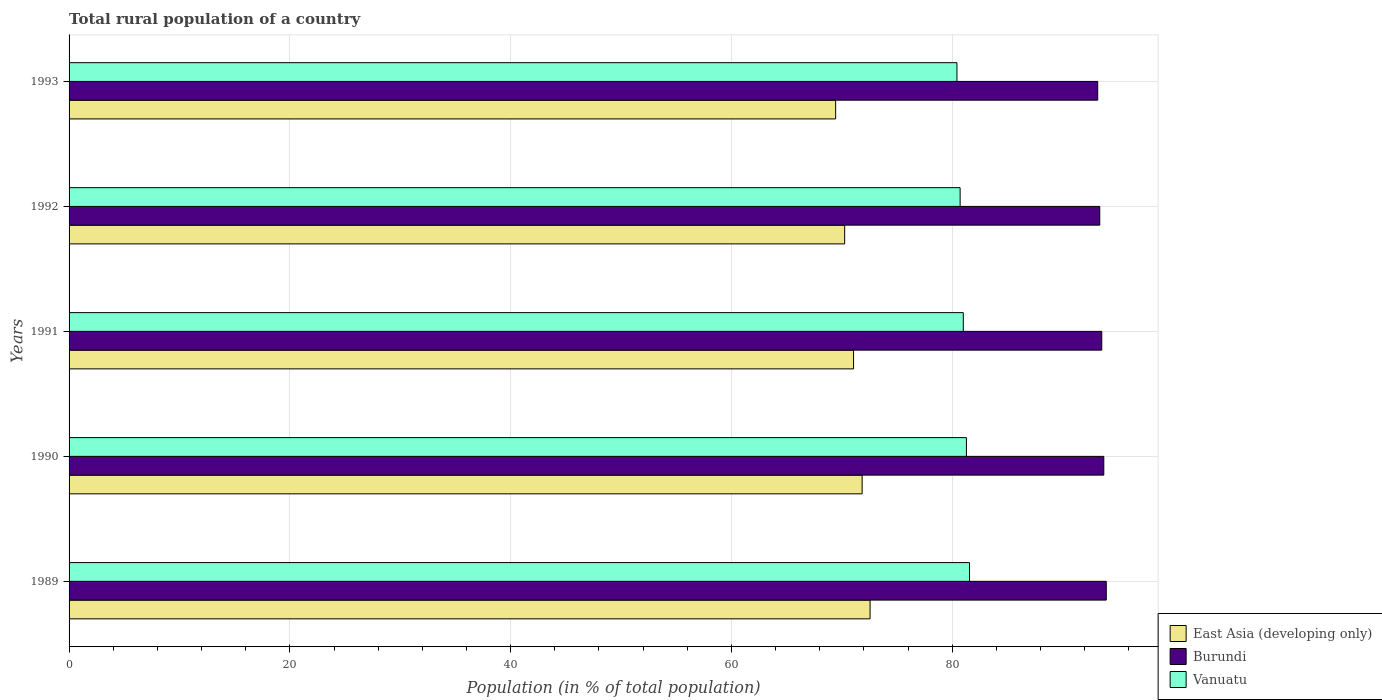How many groups of bars are there?
Offer a very short reply. 5. In how many cases, is the number of bars for a given year not equal to the number of legend labels?
Offer a very short reply. 0. What is the rural population in East Asia (developing only) in 1989?
Give a very brief answer. 72.56. Across all years, what is the maximum rural population in East Asia (developing only)?
Your answer should be very brief. 72.56. Across all years, what is the minimum rural population in Vanuatu?
Provide a short and direct response. 80.43. What is the total rural population in East Asia (developing only) in the graph?
Offer a very short reply. 355.15. What is the difference between the rural population in East Asia (developing only) in 1989 and that in 1993?
Your answer should be very brief. 3.12. What is the difference between the rural population in Burundi in 1991 and the rural population in Vanuatu in 1989?
Offer a terse response. 11.98. What is the average rural population in Burundi per year?
Provide a succinct answer. 93.55. In the year 1989, what is the difference between the rural population in Vanuatu and rural population in Burundi?
Provide a succinct answer. -12.39. In how many years, is the rural population in Vanuatu greater than 64 %?
Provide a short and direct response. 5. What is the ratio of the rural population in Burundi in 1992 to that in 1993?
Ensure brevity in your answer.  1. Is the rural population in Burundi in 1989 less than that in 1991?
Your answer should be very brief. No. Is the difference between the rural population in Vanuatu in 1992 and 1993 greater than the difference between the rural population in Burundi in 1992 and 1993?
Give a very brief answer. Yes. What is the difference between the highest and the second highest rural population in East Asia (developing only)?
Ensure brevity in your answer.  0.72. What is the difference between the highest and the lowest rural population in Burundi?
Keep it short and to the point. 0.78. What does the 3rd bar from the top in 1990 represents?
Offer a very short reply. East Asia (developing only). What does the 2nd bar from the bottom in 1990 represents?
Provide a succinct answer. Burundi. Is it the case that in every year, the sum of the rural population in Vanuatu and rural population in East Asia (developing only) is greater than the rural population in Burundi?
Make the answer very short. Yes. How many years are there in the graph?
Offer a terse response. 5. Are the values on the major ticks of X-axis written in scientific E-notation?
Give a very brief answer. No. Does the graph contain any zero values?
Your answer should be compact. No. Where does the legend appear in the graph?
Ensure brevity in your answer.  Bottom right. How many legend labels are there?
Provide a short and direct response. 3. What is the title of the graph?
Your answer should be very brief. Total rural population of a country. Does "Sint Maarten (Dutch part)" appear as one of the legend labels in the graph?
Offer a terse response. No. What is the label or title of the X-axis?
Your answer should be compact. Population (in % of total population). What is the label or title of the Y-axis?
Provide a short and direct response. Years. What is the Population (in % of total population) in East Asia (developing only) in 1989?
Give a very brief answer. 72.56. What is the Population (in % of total population) of Burundi in 1989?
Keep it short and to the point. 93.95. What is the Population (in % of total population) of Vanuatu in 1989?
Give a very brief answer. 81.56. What is the Population (in % of total population) of East Asia (developing only) in 1990?
Give a very brief answer. 71.84. What is the Population (in % of total population) in Burundi in 1990?
Provide a short and direct response. 93.73. What is the Population (in % of total population) of Vanuatu in 1990?
Your response must be concise. 81.28. What is the Population (in % of total population) of East Asia (developing only) in 1991?
Provide a short and direct response. 71.06. What is the Population (in % of total population) in Burundi in 1991?
Keep it short and to the point. 93.55. What is the Population (in % of total population) of Vanuatu in 1991?
Ensure brevity in your answer.  81. What is the Population (in % of total population) in East Asia (developing only) in 1992?
Give a very brief answer. 70.26. What is the Population (in % of total population) in Burundi in 1992?
Provide a short and direct response. 93.36. What is the Population (in % of total population) of Vanuatu in 1992?
Keep it short and to the point. 80.72. What is the Population (in % of total population) of East Asia (developing only) in 1993?
Offer a terse response. 69.44. What is the Population (in % of total population) of Burundi in 1993?
Make the answer very short. 93.18. What is the Population (in % of total population) in Vanuatu in 1993?
Give a very brief answer. 80.43. Across all years, what is the maximum Population (in % of total population) of East Asia (developing only)?
Ensure brevity in your answer.  72.56. Across all years, what is the maximum Population (in % of total population) in Burundi?
Give a very brief answer. 93.95. Across all years, what is the maximum Population (in % of total population) of Vanuatu?
Offer a terse response. 81.56. Across all years, what is the minimum Population (in % of total population) of East Asia (developing only)?
Your answer should be compact. 69.44. Across all years, what is the minimum Population (in % of total population) in Burundi?
Make the answer very short. 93.18. Across all years, what is the minimum Population (in % of total population) of Vanuatu?
Make the answer very short. 80.43. What is the total Population (in % of total population) of East Asia (developing only) in the graph?
Offer a terse response. 355.15. What is the total Population (in % of total population) of Burundi in the graph?
Give a very brief answer. 467.77. What is the total Population (in % of total population) in Vanuatu in the graph?
Ensure brevity in your answer.  404.99. What is the difference between the Population (in % of total population) in East Asia (developing only) in 1989 and that in 1990?
Your response must be concise. 0.72. What is the difference between the Population (in % of total population) in Burundi in 1989 and that in 1990?
Your answer should be compact. 0.22. What is the difference between the Population (in % of total population) in Vanuatu in 1989 and that in 1990?
Offer a terse response. 0.28. What is the difference between the Population (in % of total population) of East Asia (developing only) in 1989 and that in 1991?
Keep it short and to the point. 1.5. What is the difference between the Population (in % of total population) in Burundi in 1989 and that in 1991?
Your response must be concise. 0.41. What is the difference between the Population (in % of total population) of Vanuatu in 1989 and that in 1991?
Ensure brevity in your answer.  0.56. What is the difference between the Population (in % of total population) in East Asia (developing only) in 1989 and that in 1992?
Offer a terse response. 2.3. What is the difference between the Population (in % of total population) in Burundi in 1989 and that in 1992?
Your answer should be compact. 0.59. What is the difference between the Population (in % of total population) in East Asia (developing only) in 1989 and that in 1993?
Provide a succinct answer. 3.12. What is the difference between the Population (in % of total population) of Burundi in 1989 and that in 1993?
Your answer should be compact. 0.78. What is the difference between the Population (in % of total population) in Vanuatu in 1989 and that in 1993?
Keep it short and to the point. 1.14. What is the difference between the Population (in % of total population) of East Asia (developing only) in 1990 and that in 1991?
Make the answer very short. 0.78. What is the difference between the Population (in % of total population) of Burundi in 1990 and that in 1991?
Your answer should be compact. 0.18. What is the difference between the Population (in % of total population) of Vanuatu in 1990 and that in 1991?
Keep it short and to the point. 0.28. What is the difference between the Population (in % of total population) in East Asia (developing only) in 1990 and that in 1992?
Your response must be concise. 1.58. What is the difference between the Population (in % of total population) in Burundi in 1990 and that in 1992?
Provide a short and direct response. 0.37. What is the difference between the Population (in % of total population) in Vanuatu in 1990 and that in 1992?
Your response must be concise. 0.57. What is the difference between the Population (in % of total population) of East Asia (developing only) in 1990 and that in 1993?
Offer a very short reply. 2.4. What is the difference between the Population (in % of total population) of Burundi in 1990 and that in 1993?
Provide a short and direct response. 0.55. What is the difference between the Population (in % of total population) in Vanuatu in 1990 and that in 1993?
Provide a succinct answer. 0.86. What is the difference between the Population (in % of total population) in East Asia (developing only) in 1991 and that in 1992?
Your answer should be compact. 0.8. What is the difference between the Population (in % of total population) in Burundi in 1991 and that in 1992?
Keep it short and to the point. 0.18. What is the difference between the Population (in % of total population) in Vanuatu in 1991 and that in 1992?
Keep it short and to the point. 0.29. What is the difference between the Population (in % of total population) in East Asia (developing only) in 1991 and that in 1993?
Keep it short and to the point. 1.62. What is the difference between the Population (in % of total population) in Burundi in 1991 and that in 1993?
Make the answer very short. 0.37. What is the difference between the Population (in % of total population) of Vanuatu in 1991 and that in 1993?
Offer a terse response. 0.58. What is the difference between the Population (in % of total population) of East Asia (developing only) in 1992 and that in 1993?
Ensure brevity in your answer.  0.82. What is the difference between the Population (in % of total population) of Burundi in 1992 and that in 1993?
Your answer should be compact. 0.19. What is the difference between the Population (in % of total population) of Vanuatu in 1992 and that in 1993?
Offer a terse response. 0.29. What is the difference between the Population (in % of total population) of East Asia (developing only) in 1989 and the Population (in % of total population) of Burundi in 1990?
Offer a very short reply. -21.17. What is the difference between the Population (in % of total population) of East Asia (developing only) in 1989 and the Population (in % of total population) of Vanuatu in 1990?
Your answer should be very brief. -8.73. What is the difference between the Population (in % of total population) in Burundi in 1989 and the Population (in % of total population) in Vanuatu in 1990?
Your response must be concise. 12.67. What is the difference between the Population (in % of total population) of East Asia (developing only) in 1989 and the Population (in % of total population) of Burundi in 1991?
Make the answer very short. -20.99. What is the difference between the Population (in % of total population) of East Asia (developing only) in 1989 and the Population (in % of total population) of Vanuatu in 1991?
Your response must be concise. -8.44. What is the difference between the Population (in % of total population) of Burundi in 1989 and the Population (in % of total population) of Vanuatu in 1991?
Ensure brevity in your answer.  12.95. What is the difference between the Population (in % of total population) in East Asia (developing only) in 1989 and the Population (in % of total population) in Burundi in 1992?
Your answer should be compact. -20.81. What is the difference between the Population (in % of total population) of East Asia (developing only) in 1989 and the Population (in % of total population) of Vanuatu in 1992?
Your response must be concise. -8.16. What is the difference between the Population (in % of total population) in Burundi in 1989 and the Population (in % of total population) in Vanuatu in 1992?
Offer a very short reply. 13.24. What is the difference between the Population (in % of total population) in East Asia (developing only) in 1989 and the Population (in % of total population) in Burundi in 1993?
Keep it short and to the point. -20.62. What is the difference between the Population (in % of total population) of East Asia (developing only) in 1989 and the Population (in % of total population) of Vanuatu in 1993?
Offer a very short reply. -7.87. What is the difference between the Population (in % of total population) in Burundi in 1989 and the Population (in % of total population) in Vanuatu in 1993?
Your response must be concise. 13.53. What is the difference between the Population (in % of total population) in East Asia (developing only) in 1990 and the Population (in % of total population) in Burundi in 1991?
Provide a succinct answer. -21.71. What is the difference between the Population (in % of total population) in East Asia (developing only) in 1990 and the Population (in % of total population) in Vanuatu in 1991?
Offer a very short reply. -9.16. What is the difference between the Population (in % of total population) in Burundi in 1990 and the Population (in % of total population) in Vanuatu in 1991?
Give a very brief answer. 12.73. What is the difference between the Population (in % of total population) of East Asia (developing only) in 1990 and the Population (in % of total population) of Burundi in 1992?
Give a very brief answer. -21.52. What is the difference between the Population (in % of total population) of East Asia (developing only) in 1990 and the Population (in % of total population) of Vanuatu in 1992?
Offer a very short reply. -8.88. What is the difference between the Population (in % of total population) of Burundi in 1990 and the Population (in % of total population) of Vanuatu in 1992?
Your response must be concise. 13.01. What is the difference between the Population (in % of total population) of East Asia (developing only) in 1990 and the Population (in % of total population) of Burundi in 1993?
Give a very brief answer. -21.34. What is the difference between the Population (in % of total population) of East Asia (developing only) in 1990 and the Population (in % of total population) of Vanuatu in 1993?
Keep it short and to the point. -8.59. What is the difference between the Population (in % of total population) of Burundi in 1990 and the Population (in % of total population) of Vanuatu in 1993?
Provide a short and direct response. 13.3. What is the difference between the Population (in % of total population) of East Asia (developing only) in 1991 and the Population (in % of total population) of Burundi in 1992?
Offer a very short reply. -22.3. What is the difference between the Population (in % of total population) in East Asia (developing only) in 1991 and the Population (in % of total population) in Vanuatu in 1992?
Offer a very short reply. -9.65. What is the difference between the Population (in % of total population) of Burundi in 1991 and the Population (in % of total population) of Vanuatu in 1992?
Offer a very short reply. 12.83. What is the difference between the Population (in % of total population) of East Asia (developing only) in 1991 and the Population (in % of total population) of Burundi in 1993?
Ensure brevity in your answer.  -22.12. What is the difference between the Population (in % of total population) of East Asia (developing only) in 1991 and the Population (in % of total population) of Vanuatu in 1993?
Offer a terse response. -9.37. What is the difference between the Population (in % of total population) of Burundi in 1991 and the Population (in % of total population) of Vanuatu in 1993?
Your answer should be compact. 13.12. What is the difference between the Population (in % of total population) of East Asia (developing only) in 1992 and the Population (in % of total population) of Burundi in 1993?
Offer a very short reply. -22.92. What is the difference between the Population (in % of total population) of East Asia (developing only) in 1992 and the Population (in % of total population) of Vanuatu in 1993?
Your answer should be compact. -10.17. What is the difference between the Population (in % of total population) in Burundi in 1992 and the Population (in % of total population) in Vanuatu in 1993?
Your answer should be compact. 12.94. What is the average Population (in % of total population) in East Asia (developing only) per year?
Make the answer very short. 71.03. What is the average Population (in % of total population) in Burundi per year?
Ensure brevity in your answer.  93.55. What is the average Population (in % of total population) of Vanuatu per year?
Provide a succinct answer. 81. In the year 1989, what is the difference between the Population (in % of total population) in East Asia (developing only) and Population (in % of total population) in Burundi?
Provide a short and direct response. -21.4. In the year 1989, what is the difference between the Population (in % of total population) of East Asia (developing only) and Population (in % of total population) of Vanuatu?
Make the answer very short. -9.01. In the year 1989, what is the difference between the Population (in % of total population) in Burundi and Population (in % of total population) in Vanuatu?
Provide a short and direct response. 12.39. In the year 1990, what is the difference between the Population (in % of total population) in East Asia (developing only) and Population (in % of total population) in Burundi?
Provide a succinct answer. -21.89. In the year 1990, what is the difference between the Population (in % of total population) in East Asia (developing only) and Population (in % of total population) in Vanuatu?
Ensure brevity in your answer.  -9.45. In the year 1990, what is the difference between the Population (in % of total population) in Burundi and Population (in % of total population) in Vanuatu?
Offer a very short reply. 12.44. In the year 1991, what is the difference between the Population (in % of total population) in East Asia (developing only) and Population (in % of total population) in Burundi?
Make the answer very short. -22.48. In the year 1991, what is the difference between the Population (in % of total population) of East Asia (developing only) and Population (in % of total population) of Vanuatu?
Keep it short and to the point. -9.94. In the year 1991, what is the difference between the Population (in % of total population) of Burundi and Population (in % of total population) of Vanuatu?
Make the answer very short. 12.54. In the year 1992, what is the difference between the Population (in % of total population) in East Asia (developing only) and Population (in % of total population) in Burundi?
Your response must be concise. -23.11. In the year 1992, what is the difference between the Population (in % of total population) in East Asia (developing only) and Population (in % of total population) in Vanuatu?
Provide a succinct answer. -10.46. In the year 1992, what is the difference between the Population (in % of total population) of Burundi and Population (in % of total population) of Vanuatu?
Your response must be concise. 12.65. In the year 1993, what is the difference between the Population (in % of total population) of East Asia (developing only) and Population (in % of total population) of Burundi?
Your response must be concise. -23.74. In the year 1993, what is the difference between the Population (in % of total population) in East Asia (developing only) and Population (in % of total population) in Vanuatu?
Make the answer very short. -10.99. In the year 1993, what is the difference between the Population (in % of total population) in Burundi and Population (in % of total population) in Vanuatu?
Give a very brief answer. 12.75. What is the ratio of the Population (in % of total population) of East Asia (developing only) in 1989 to that in 1990?
Make the answer very short. 1.01. What is the ratio of the Population (in % of total population) of Burundi in 1989 to that in 1990?
Give a very brief answer. 1. What is the ratio of the Population (in % of total population) in Vanuatu in 1989 to that in 1990?
Ensure brevity in your answer.  1. What is the ratio of the Population (in % of total population) in East Asia (developing only) in 1989 to that in 1991?
Your response must be concise. 1.02. What is the ratio of the Population (in % of total population) in Burundi in 1989 to that in 1991?
Give a very brief answer. 1. What is the ratio of the Population (in % of total population) in East Asia (developing only) in 1989 to that in 1992?
Offer a terse response. 1.03. What is the ratio of the Population (in % of total population) of Vanuatu in 1989 to that in 1992?
Make the answer very short. 1.01. What is the ratio of the Population (in % of total population) in East Asia (developing only) in 1989 to that in 1993?
Offer a terse response. 1.04. What is the ratio of the Population (in % of total population) in Burundi in 1989 to that in 1993?
Make the answer very short. 1.01. What is the ratio of the Population (in % of total population) of Vanuatu in 1989 to that in 1993?
Give a very brief answer. 1.01. What is the ratio of the Population (in % of total population) of East Asia (developing only) in 1990 to that in 1991?
Provide a short and direct response. 1.01. What is the ratio of the Population (in % of total population) in East Asia (developing only) in 1990 to that in 1992?
Make the answer very short. 1.02. What is the ratio of the Population (in % of total population) in Burundi in 1990 to that in 1992?
Your answer should be very brief. 1. What is the ratio of the Population (in % of total population) in Vanuatu in 1990 to that in 1992?
Keep it short and to the point. 1.01. What is the ratio of the Population (in % of total population) in East Asia (developing only) in 1990 to that in 1993?
Make the answer very short. 1.03. What is the ratio of the Population (in % of total population) in Burundi in 1990 to that in 1993?
Ensure brevity in your answer.  1.01. What is the ratio of the Population (in % of total population) of Vanuatu in 1990 to that in 1993?
Offer a terse response. 1.01. What is the ratio of the Population (in % of total population) in East Asia (developing only) in 1991 to that in 1992?
Provide a short and direct response. 1.01. What is the ratio of the Population (in % of total population) in East Asia (developing only) in 1991 to that in 1993?
Your answer should be compact. 1.02. What is the ratio of the Population (in % of total population) in East Asia (developing only) in 1992 to that in 1993?
Offer a terse response. 1.01. What is the ratio of the Population (in % of total population) of Vanuatu in 1992 to that in 1993?
Offer a terse response. 1. What is the difference between the highest and the second highest Population (in % of total population) in East Asia (developing only)?
Provide a succinct answer. 0.72. What is the difference between the highest and the second highest Population (in % of total population) of Burundi?
Your answer should be very brief. 0.22. What is the difference between the highest and the second highest Population (in % of total population) of Vanuatu?
Provide a succinct answer. 0.28. What is the difference between the highest and the lowest Population (in % of total population) of East Asia (developing only)?
Provide a short and direct response. 3.12. What is the difference between the highest and the lowest Population (in % of total population) in Burundi?
Your answer should be very brief. 0.78. What is the difference between the highest and the lowest Population (in % of total population) of Vanuatu?
Provide a succinct answer. 1.14. 